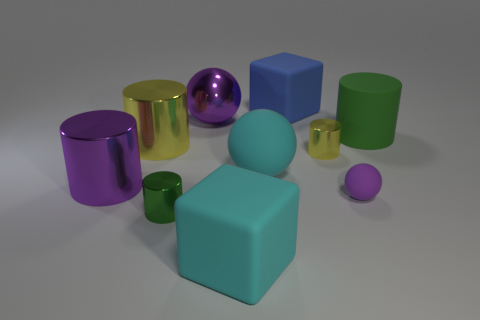What materials do the objects in the image seem to be made of? The objects in the image appear to be made of various materials; some have reflective surfaces suggesting they could be metals or plastics with shiny coatings, while the textured green cylinders might be made of a rubbery material. 